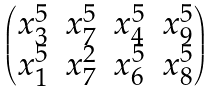Convert formula to latex. <formula><loc_0><loc_0><loc_500><loc_500>\begin{pmatrix} x _ { 3 } ^ { 5 } & x _ { 7 } ^ { 5 } & x _ { 4 } ^ { 5 } & x _ { 9 } ^ { 5 } \\ x _ { 1 } ^ { 5 } & x _ { 7 } ^ { 2 } & x _ { 6 } ^ { 5 } & x _ { 8 } ^ { 5 } \end{pmatrix}</formula> 